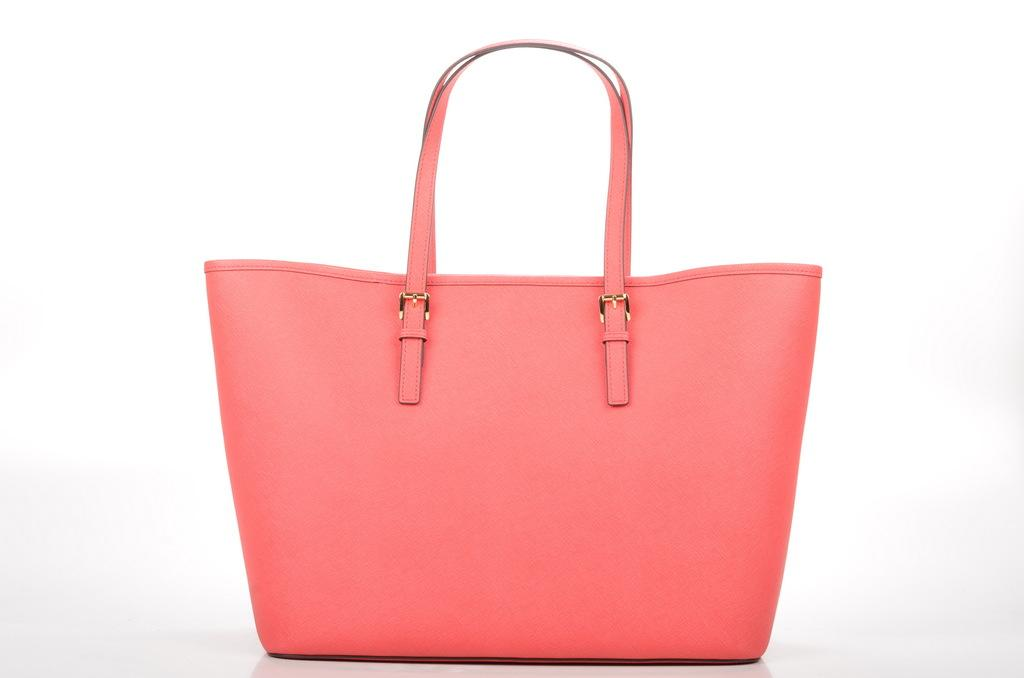What color is the bag that is visible in the image? The bag is peach-colored. How is the bag emphasized or made noticeable in the image? The bag is highlighted in the image. Can you see any fangs in the image? There are no fangs present in the image. 